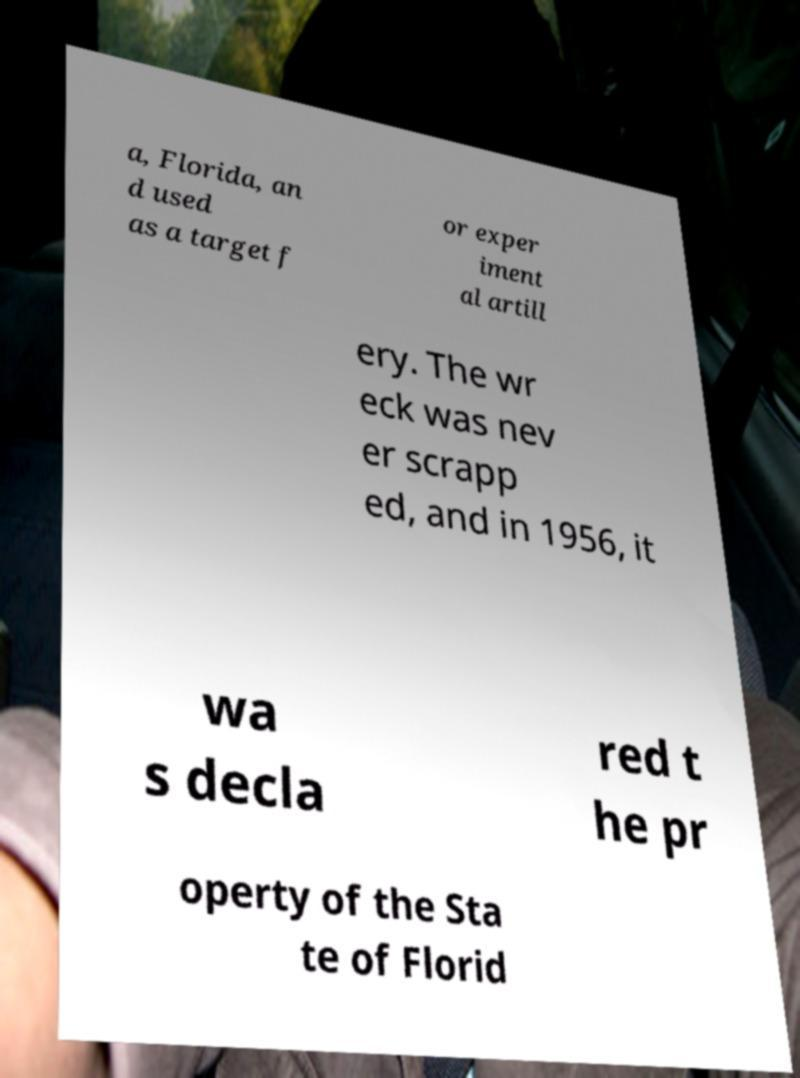Can you read and provide the text displayed in the image?This photo seems to have some interesting text. Can you extract and type it out for me? a, Florida, an d used as a target f or exper iment al artill ery. The wr eck was nev er scrapp ed, and in 1956, it wa s decla red t he pr operty of the Sta te of Florid 